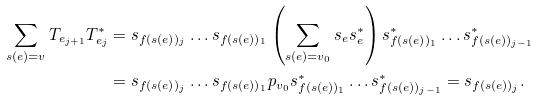Convert formula to latex. <formula><loc_0><loc_0><loc_500><loc_500>\sum _ { s ( e ) = v } T _ { e _ { j + 1 } } T _ { e _ { j } } ^ { * } & = s _ { f ( s ( e ) ) _ { j } } \dots s _ { f ( s ( e ) ) _ { 1 } } \left ( \sum _ { s ( e ) = v _ { 0 } } s _ { e } s _ { e } ^ { * } \right ) s _ { f ( s ( e ) ) _ { 1 } } ^ { * } \dots s _ { f ( s ( e ) ) _ { j - 1 } } ^ { * } \\ & = s _ { f ( s ( e ) ) _ { j } } \dots s _ { f ( s ( e ) ) _ { 1 } } p _ { v _ { 0 } } s _ { f ( s ( e ) ) _ { 1 } } ^ { * } \dots s _ { f ( s ( e ) ) _ { j - 1 } } ^ { * } = s _ { f ( s ( e ) ) _ { j } } .</formula> 